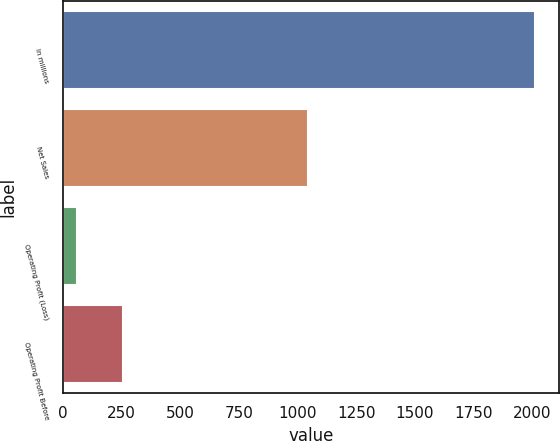<chart> <loc_0><loc_0><loc_500><loc_500><bar_chart><fcel>In millions<fcel>Net Sales<fcel>Operating Profit (Loss)<fcel>Operating Profit Before<nl><fcel>2014<fcel>1046<fcel>61<fcel>256.3<nl></chart> 